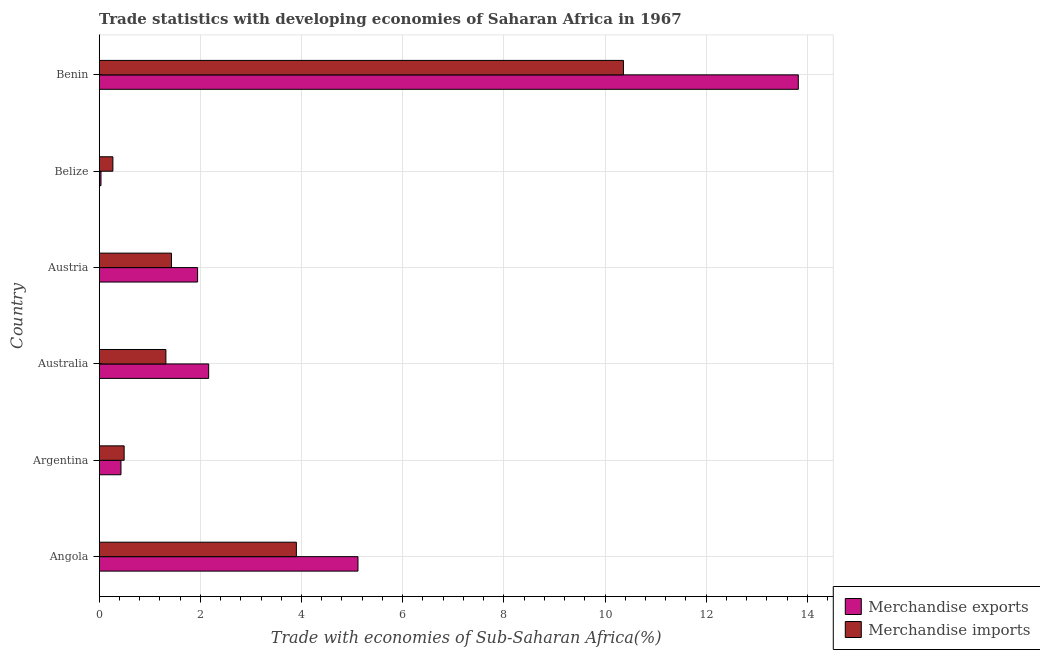How many groups of bars are there?
Keep it short and to the point. 6. Are the number of bars per tick equal to the number of legend labels?
Make the answer very short. Yes. How many bars are there on the 3rd tick from the top?
Provide a short and direct response. 2. How many bars are there on the 6th tick from the bottom?
Offer a terse response. 2. What is the label of the 5th group of bars from the top?
Provide a succinct answer. Argentina. What is the merchandise imports in Angola?
Give a very brief answer. 3.9. Across all countries, what is the maximum merchandise exports?
Your response must be concise. 13.82. Across all countries, what is the minimum merchandise imports?
Provide a short and direct response. 0.27. In which country was the merchandise imports maximum?
Your answer should be very brief. Benin. In which country was the merchandise imports minimum?
Keep it short and to the point. Belize. What is the total merchandise imports in the graph?
Make the answer very short. 17.77. What is the difference between the merchandise imports in Angola and that in Australia?
Offer a terse response. 2.58. What is the difference between the merchandise exports in Argentina and the merchandise imports in Australia?
Your response must be concise. -0.89. What is the average merchandise exports per country?
Give a very brief answer. 3.92. What is the difference between the merchandise exports and merchandise imports in Benin?
Offer a very short reply. 3.46. In how many countries, is the merchandise imports greater than 14 %?
Keep it short and to the point. 0. What is the ratio of the merchandise imports in Belize to that in Benin?
Ensure brevity in your answer.  0.03. Is the difference between the merchandise exports in Australia and Benin greater than the difference between the merchandise imports in Australia and Benin?
Keep it short and to the point. No. What is the difference between the highest and the second highest merchandise exports?
Your response must be concise. 8.71. What is the difference between the highest and the lowest merchandise exports?
Your answer should be compact. 13.79. What does the 1st bar from the top in Argentina represents?
Your answer should be very brief. Merchandise imports. Are all the bars in the graph horizontal?
Your response must be concise. Yes. How many countries are there in the graph?
Offer a terse response. 6. How are the legend labels stacked?
Keep it short and to the point. Vertical. What is the title of the graph?
Ensure brevity in your answer.  Trade statistics with developing economies of Saharan Africa in 1967. What is the label or title of the X-axis?
Provide a short and direct response. Trade with economies of Sub-Saharan Africa(%). What is the Trade with economies of Sub-Saharan Africa(%) of Merchandise exports in Angola?
Keep it short and to the point. 5.12. What is the Trade with economies of Sub-Saharan Africa(%) in Merchandise imports in Angola?
Your response must be concise. 3.9. What is the Trade with economies of Sub-Saharan Africa(%) of Merchandise exports in Argentina?
Give a very brief answer. 0.43. What is the Trade with economies of Sub-Saharan Africa(%) of Merchandise imports in Argentina?
Ensure brevity in your answer.  0.49. What is the Trade with economies of Sub-Saharan Africa(%) of Merchandise exports in Australia?
Your answer should be very brief. 2.16. What is the Trade with economies of Sub-Saharan Africa(%) of Merchandise imports in Australia?
Your answer should be very brief. 1.32. What is the Trade with economies of Sub-Saharan Africa(%) of Merchandise exports in Austria?
Provide a succinct answer. 1.94. What is the Trade with economies of Sub-Saharan Africa(%) of Merchandise imports in Austria?
Make the answer very short. 1.43. What is the Trade with economies of Sub-Saharan Africa(%) of Merchandise exports in Belize?
Give a very brief answer. 0.03. What is the Trade with economies of Sub-Saharan Africa(%) of Merchandise imports in Belize?
Your response must be concise. 0.27. What is the Trade with economies of Sub-Saharan Africa(%) in Merchandise exports in Benin?
Offer a terse response. 13.82. What is the Trade with economies of Sub-Saharan Africa(%) of Merchandise imports in Benin?
Offer a terse response. 10.37. Across all countries, what is the maximum Trade with economies of Sub-Saharan Africa(%) in Merchandise exports?
Your answer should be very brief. 13.82. Across all countries, what is the maximum Trade with economies of Sub-Saharan Africa(%) in Merchandise imports?
Keep it short and to the point. 10.37. Across all countries, what is the minimum Trade with economies of Sub-Saharan Africa(%) of Merchandise exports?
Give a very brief answer. 0.03. Across all countries, what is the minimum Trade with economies of Sub-Saharan Africa(%) of Merchandise imports?
Provide a short and direct response. 0.27. What is the total Trade with economies of Sub-Saharan Africa(%) in Merchandise exports in the graph?
Keep it short and to the point. 23.51. What is the total Trade with economies of Sub-Saharan Africa(%) in Merchandise imports in the graph?
Provide a short and direct response. 17.77. What is the difference between the Trade with economies of Sub-Saharan Africa(%) in Merchandise exports in Angola and that in Argentina?
Provide a short and direct response. 4.69. What is the difference between the Trade with economies of Sub-Saharan Africa(%) in Merchandise imports in Angola and that in Argentina?
Ensure brevity in your answer.  3.41. What is the difference between the Trade with economies of Sub-Saharan Africa(%) in Merchandise exports in Angola and that in Australia?
Keep it short and to the point. 2.95. What is the difference between the Trade with economies of Sub-Saharan Africa(%) in Merchandise imports in Angola and that in Australia?
Provide a succinct answer. 2.58. What is the difference between the Trade with economies of Sub-Saharan Africa(%) of Merchandise exports in Angola and that in Austria?
Provide a short and direct response. 3.17. What is the difference between the Trade with economies of Sub-Saharan Africa(%) in Merchandise imports in Angola and that in Austria?
Provide a short and direct response. 2.47. What is the difference between the Trade with economies of Sub-Saharan Africa(%) of Merchandise exports in Angola and that in Belize?
Ensure brevity in your answer.  5.08. What is the difference between the Trade with economies of Sub-Saharan Africa(%) in Merchandise imports in Angola and that in Belize?
Ensure brevity in your answer.  3.63. What is the difference between the Trade with economies of Sub-Saharan Africa(%) of Merchandise exports in Angola and that in Benin?
Your response must be concise. -8.71. What is the difference between the Trade with economies of Sub-Saharan Africa(%) in Merchandise imports in Angola and that in Benin?
Offer a very short reply. -6.47. What is the difference between the Trade with economies of Sub-Saharan Africa(%) of Merchandise exports in Argentina and that in Australia?
Your answer should be compact. -1.73. What is the difference between the Trade with economies of Sub-Saharan Africa(%) in Merchandise imports in Argentina and that in Australia?
Give a very brief answer. -0.83. What is the difference between the Trade with economies of Sub-Saharan Africa(%) of Merchandise exports in Argentina and that in Austria?
Give a very brief answer. -1.51. What is the difference between the Trade with economies of Sub-Saharan Africa(%) in Merchandise imports in Argentina and that in Austria?
Ensure brevity in your answer.  -0.94. What is the difference between the Trade with economies of Sub-Saharan Africa(%) of Merchandise exports in Argentina and that in Belize?
Offer a terse response. 0.4. What is the difference between the Trade with economies of Sub-Saharan Africa(%) in Merchandise imports in Argentina and that in Belize?
Your answer should be very brief. 0.22. What is the difference between the Trade with economies of Sub-Saharan Africa(%) of Merchandise exports in Argentina and that in Benin?
Offer a terse response. -13.39. What is the difference between the Trade with economies of Sub-Saharan Africa(%) of Merchandise imports in Argentina and that in Benin?
Keep it short and to the point. -9.87. What is the difference between the Trade with economies of Sub-Saharan Africa(%) in Merchandise exports in Australia and that in Austria?
Keep it short and to the point. 0.22. What is the difference between the Trade with economies of Sub-Saharan Africa(%) in Merchandise imports in Australia and that in Austria?
Offer a terse response. -0.11. What is the difference between the Trade with economies of Sub-Saharan Africa(%) in Merchandise exports in Australia and that in Belize?
Your answer should be compact. 2.13. What is the difference between the Trade with economies of Sub-Saharan Africa(%) of Merchandise imports in Australia and that in Belize?
Make the answer very short. 1.05. What is the difference between the Trade with economies of Sub-Saharan Africa(%) of Merchandise exports in Australia and that in Benin?
Make the answer very short. -11.66. What is the difference between the Trade with economies of Sub-Saharan Africa(%) of Merchandise imports in Australia and that in Benin?
Your answer should be compact. -9.05. What is the difference between the Trade with economies of Sub-Saharan Africa(%) in Merchandise exports in Austria and that in Belize?
Provide a succinct answer. 1.91. What is the difference between the Trade with economies of Sub-Saharan Africa(%) of Merchandise imports in Austria and that in Belize?
Provide a short and direct response. 1.16. What is the difference between the Trade with economies of Sub-Saharan Africa(%) of Merchandise exports in Austria and that in Benin?
Provide a succinct answer. -11.88. What is the difference between the Trade with economies of Sub-Saharan Africa(%) in Merchandise imports in Austria and that in Benin?
Make the answer very short. -8.94. What is the difference between the Trade with economies of Sub-Saharan Africa(%) in Merchandise exports in Belize and that in Benin?
Your answer should be very brief. -13.79. What is the difference between the Trade with economies of Sub-Saharan Africa(%) of Merchandise imports in Belize and that in Benin?
Your response must be concise. -10.09. What is the difference between the Trade with economies of Sub-Saharan Africa(%) in Merchandise exports in Angola and the Trade with economies of Sub-Saharan Africa(%) in Merchandise imports in Argentina?
Make the answer very short. 4.62. What is the difference between the Trade with economies of Sub-Saharan Africa(%) in Merchandise exports in Angola and the Trade with economies of Sub-Saharan Africa(%) in Merchandise imports in Australia?
Your response must be concise. 3.8. What is the difference between the Trade with economies of Sub-Saharan Africa(%) in Merchandise exports in Angola and the Trade with economies of Sub-Saharan Africa(%) in Merchandise imports in Austria?
Ensure brevity in your answer.  3.69. What is the difference between the Trade with economies of Sub-Saharan Africa(%) of Merchandise exports in Angola and the Trade with economies of Sub-Saharan Africa(%) of Merchandise imports in Belize?
Provide a succinct answer. 4.85. What is the difference between the Trade with economies of Sub-Saharan Africa(%) in Merchandise exports in Angola and the Trade with economies of Sub-Saharan Africa(%) in Merchandise imports in Benin?
Offer a terse response. -5.25. What is the difference between the Trade with economies of Sub-Saharan Africa(%) of Merchandise exports in Argentina and the Trade with economies of Sub-Saharan Africa(%) of Merchandise imports in Australia?
Ensure brevity in your answer.  -0.89. What is the difference between the Trade with economies of Sub-Saharan Africa(%) of Merchandise exports in Argentina and the Trade with economies of Sub-Saharan Africa(%) of Merchandise imports in Austria?
Provide a succinct answer. -1. What is the difference between the Trade with economies of Sub-Saharan Africa(%) of Merchandise exports in Argentina and the Trade with economies of Sub-Saharan Africa(%) of Merchandise imports in Belize?
Ensure brevity in your answer.  0.16. What is the difference between the Trade with economies of Sub-Saharan Africa(%) of Merchandise exports in Argentina and the Trade with economies of Sub-Saharan Africa(%) of Merchandise imports in Benin?
Your answer should be compact. -9.94. What is the difference between the Trade with economies of Sub-Saharan Africa(%) of Merchandise exports in Australia and the Trade with economies of Sub-Saharan Africa(%) of Merchandise imports in Austria?
Your response must be concise. 0.74. What is the difference between the Trade with economies of Sub-Saharan Africa(%) of Merchandise exports in Australia and the Trade with economies of Sub-Saharan Africa(%) of Merchandise imports in Belize?
Make the answer very short. 1.89. What is the difference between the Trade with economies of Sub-Saharan Africa(%) of Merchandise exports in Australia and the Trade with economies of Sub-Saharan Africa(%) of Merchandise imports in Benin?
Offer a terse response. -8.2. What is the difference between the Trade with economies of Sub-Saharan Africa(%) of Merchandise exports in Austria and the Trade with economies of Sub-Saharan Africa(%) of Merchandise imports in Belize?
Your response must be concise. 1.67. What is the difference between the Trade with economies of Sub-Saharan Africa(%) in Merchandise exports in Austria and the Trade with economies of Sub-Saharan Africa(%) in Merchandise imports in Benin?
Your response must be concise. -8.42. What is the difference between the Trade with economies of Sub-Saharan Africa(%) of Merchandise exports in Belize and the Trade with economies of Sub-Saharan Africa(%) of Merchandise imports in Benin?
Provide a short and direct response. -10.33. What is the average Trade with economies of Sub-Saharan Africa(%) in Merchandise exports per country?
Offer a terse response. 3.92. What is the average Trade with economies of Sub-Saharan Africa(%) in Merchandise imports per country?
Your answer should be very brief. 2.96. What is the difference between the Trade with economies of Sub-Saharan Africa(%) in Merchandise exports and Trade with economies of Sub-Saharan Africa(%) in Merchandise imports in Angola?
Ensure brevity in your answer.  1.22. What is the difference between the Trade with economies of Sub-Saharan Africa(%) in Merchandise exports and Trade with economies of Sub-Saharan Africa(%) in Merchandise imports in Argentina?
Make the answer very short. -0.06. What is the difference between the Trade with economies of Sub-Saharan Africa(%) in Merchandise exports and Trade with economies of Sub-Saharan Africa(%) in Merchandise imports in Australia?
Offer a terse response. 0.85. What is the difference between the Trade with economies of Sub-Saharan Africa(%) in Merchandise exports and Trade with economies of Sub-Saharan Africa(%) in Merchandise imports in Austria?
Your response must be concise. 0.52. What is the difference between the Trade with economies of Sub-Saharan Africa(%) of Merchandise exports and Trade with economies of Sub-Saharan Africa(%) of Merchandise imports in Belize?
Provide a succinct answer. -0.24. What is the difference between the Trade with economies of Sub-Saharan Africa(%) of Merchandise exports and Trade with economies of Sub-Saharan Africa(%) of Merchandise imports in Benin?
Ensure brevity in your answer.  3.46. What is the ratio of the Trade with economies of Sub-Saharan Africa(%) of Merchandise exports in Angola to that in Argentina?
Provide a succinct answer. 11.89. What is the ratio of the Trade with economies of Sub-Saharan Africa(%) of Merchandise imports in Angola to that in Argentina?
Ensure brevity in your answer.  7.91. What is the ratio of the Trade with economies of Sub-Saharan Africa(%) in Merchandise exports in Angola to that in Australia?
Offer a terse response. 2.36. What is the ratio of the Trade with economies of Sub-Saharan Africa(%) of Merchandise imports in Angola to that in Australia?
Your answer should be compact. 2.96. What is the ratio of the Trade with economies of Sub-Saharan Africa(%) in Merchandise exports in Angola to that in Austria?
Provide a short and direct response. 2.63. What is the ratio of the Trade with economies of Sub-Saharan Africa(%) in Merchandise imports in Angola to that in Austria?
Your answer should be compact. 2.73. What is the ratio of the Trade with economies of Sub-Saharan Africa(%) of Merchandise exports in Angola to that in Belize?
Keep it short and to the point. 146.33. What is the ratio of the Trade with economies of Sub-Saharan Africa(%) of Merchandise imports in Angola to that in Belize?
Keep it short and to the point. 14.42. What is the ratio of the Trade with economies of Sub-Saharan Africa(%) of Merchandise exports in Angola to that in Benin?
Ensure brevity in your answer.  0.37. What is the ratio of the Trade with economies of Sub-Saharan Africa(%) of Merchandise imports in Angola to that in Benin?
Provide a succinct answer. 0.38. What is the ratio of the Trade with economies of Sub-Saharan Africa(%) in Merchandise exports in Argentina to that in Australia?
Your response must be concise. 0.2. What is the ratio of the Trade with economies of Sub-Saharan Africa(%) in Merchandise imports in Argentina to that in Australia?
Ensure brevity in your answer.  0.37. What is the ratio of the Trade with economies of Sub-Saharan Africa(%) in Merchandise exports in Argentina to that in Austria?
Your answer should be compact. 0.22. What is the ratio of the Trade with economies of Sub-Saharan Africa(%) of Merchandise imports in Argentina to that in Austria?
Make the answer very short. 0.34. What is the ratio of the Trade with economies of Sub-Saharan Africa(%) of Merchandise exports in Argentina to that in Belize?
Give a very brief answer. 12.3. What is the ratio of the Trade with economies of Sub-Saharan Africa(%) of Merchandise imports in Argentina to that in Belize?
Provide a short and direct response. 1.82. What is the ratio of the Trade with economies of Sub-Saharan Africa(%) in Merchandise exports in Argentina to that in Benin?
Your response must be concise. 0.03. What is the ratio of the Trade with economies of Sub-Saharan Africa(%) of Merchandise imports in Argentina to that in Benin?
Offer a terse response. 0.05. What is the ratio of the Trade with economies of Sub-Saharan Africa(%) in Merchandise exports in Australia to that in Austria?
Keep it short and to the point. 1.11. What is the ratio of the Trade with economies of Sub-Saharan Africa(%) of Merchandise imports in Australia to that in Austria?
Make the answer very short. 0.92. What is the ratio of the Trade with economies of Sub-Saharan Africa(%) in Merchandise exports in Australia to that in Belize?
Your response must be concise. 61.89. What is the ratio of the Trade with economies of Sub-Saharan Africa(%) of Merchandise imports in Australia to that in Belize?
Your answer should be very brief. 4.87. What is the ratio of the Trade with economies of Sub-Saharan Africa(%) of Merchandise exports in Australia to that in Benin?
Offer a very short reply. 0.16. What is the ratio of the Trade with economies of Sub-Saharan Africa(%) of Merchandise imports in Australia to that in Benin?
Provide a succinct answer. 0.13. What is the ratio of the Trade with economies of Sub-Saharan Africa(%) of Merchandise exports in Austria to that in Belize?
Your answer should be very brief. 55.63. What is the ratio of the Trade with economies of Sub-Saharan Africa(%) of Merchandise imports in Austria to that in Belize?
Your answer should be compact. 5.28. What is the ratio of the Trade with economies of Sub-Saharan Africa(%) in Merchandise exports in Austria to that in Benin?
Ensure brevity in your answer.  0.14. What is the ratio of the Trade with economies of Sub-Saharan Africa(%) in Merchandise imports in Austria to that in Benin?
Give a very brief answer. 0.14. What is the ratio of the Trade with economies of Sub-Saharan Africa(%) in Merchandise exports in Belize to that in Benin?
Provide a succinct answer. 0. What is the ratio of the Trade with economies of Sub-Saharan Africa(%) in Merchandise imports in Belize to that in Benin?
Your answer should be very brief. 0.03. What is the difference between the highest and the second highest Trade with economies of Sub-Saharan Africa(%) of Merchandise exports?
Provide a succinct answer. 8.71. What is the difference between the highest and the second highest Trade with economies of Sub-Saharan Africa(%) of Merchandise imports?
Your response must be concise. 6.47. What is the difference between the highest and the lowest Trade with economies of Sub-Saharan Africa(%) of Merchandise exports?
Offer a very short reply. 13.79. What is the difference between the highest and the lowest Trade with economies of Sub-Saharan Africa(%) in Merchandise imports?
Your answer should be compact. 10.09. 